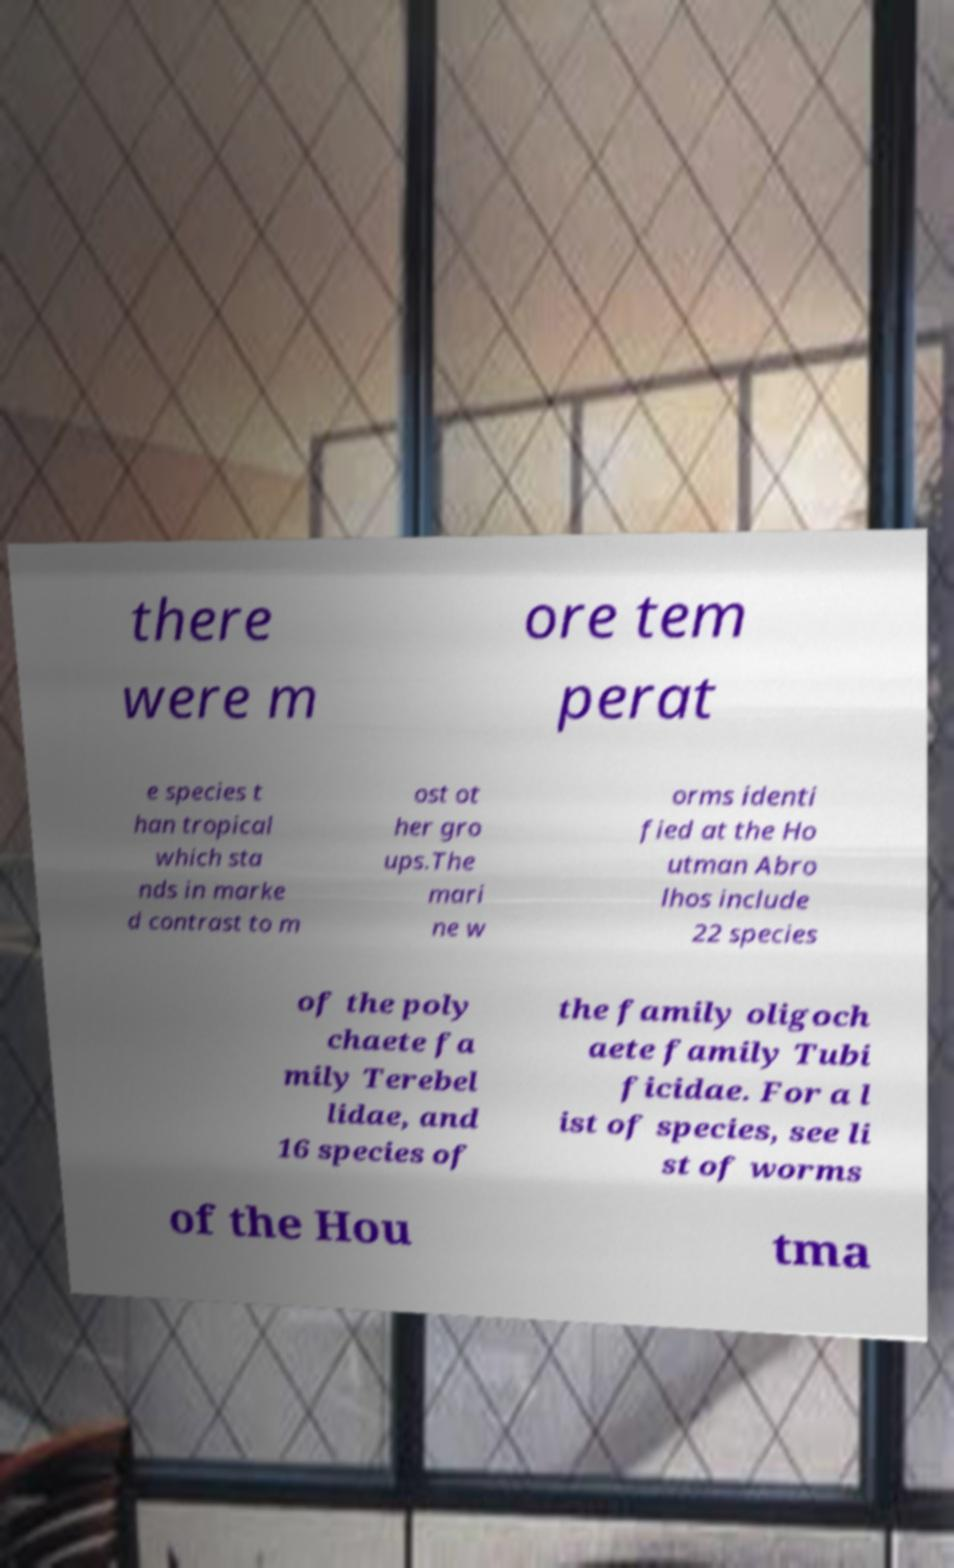There's text embedded in this image that I need extracted. Can you transcribe it verbatim? there were m ore tem perat e species t han tropical which sta nds in marke d contrast to m ost ot her gro ups.The mari ne w orms identi fied at the Ho utman Abro lhos include 22 species of the poly chaete fa mily Terebel lidae, and 16 species of the family oligoch aete family Tubi ficidae. For a l ist of species, see li st of worms of the Hou tma 